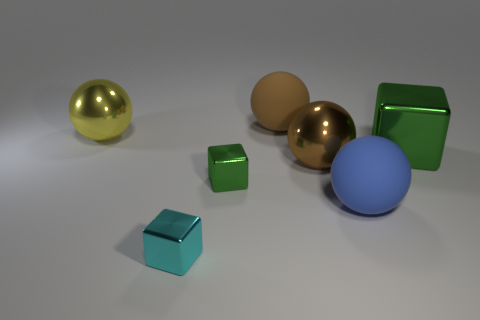Add 3 green rubber cylinders. How many objects exist? 10 Subtract all blocks. How many objects are left? 4 Subtract all big purple rubber spheres. Subtract all tiny cyan objects. How many objects are left? 6 Add 2 tiny green shiny objects. How many tiny green shiny objects are left? 3 Add 2 big blue rubber things. How many big blue rubber things exist? 3 Subtract 0 red cylinders. How many objects are left? 7 